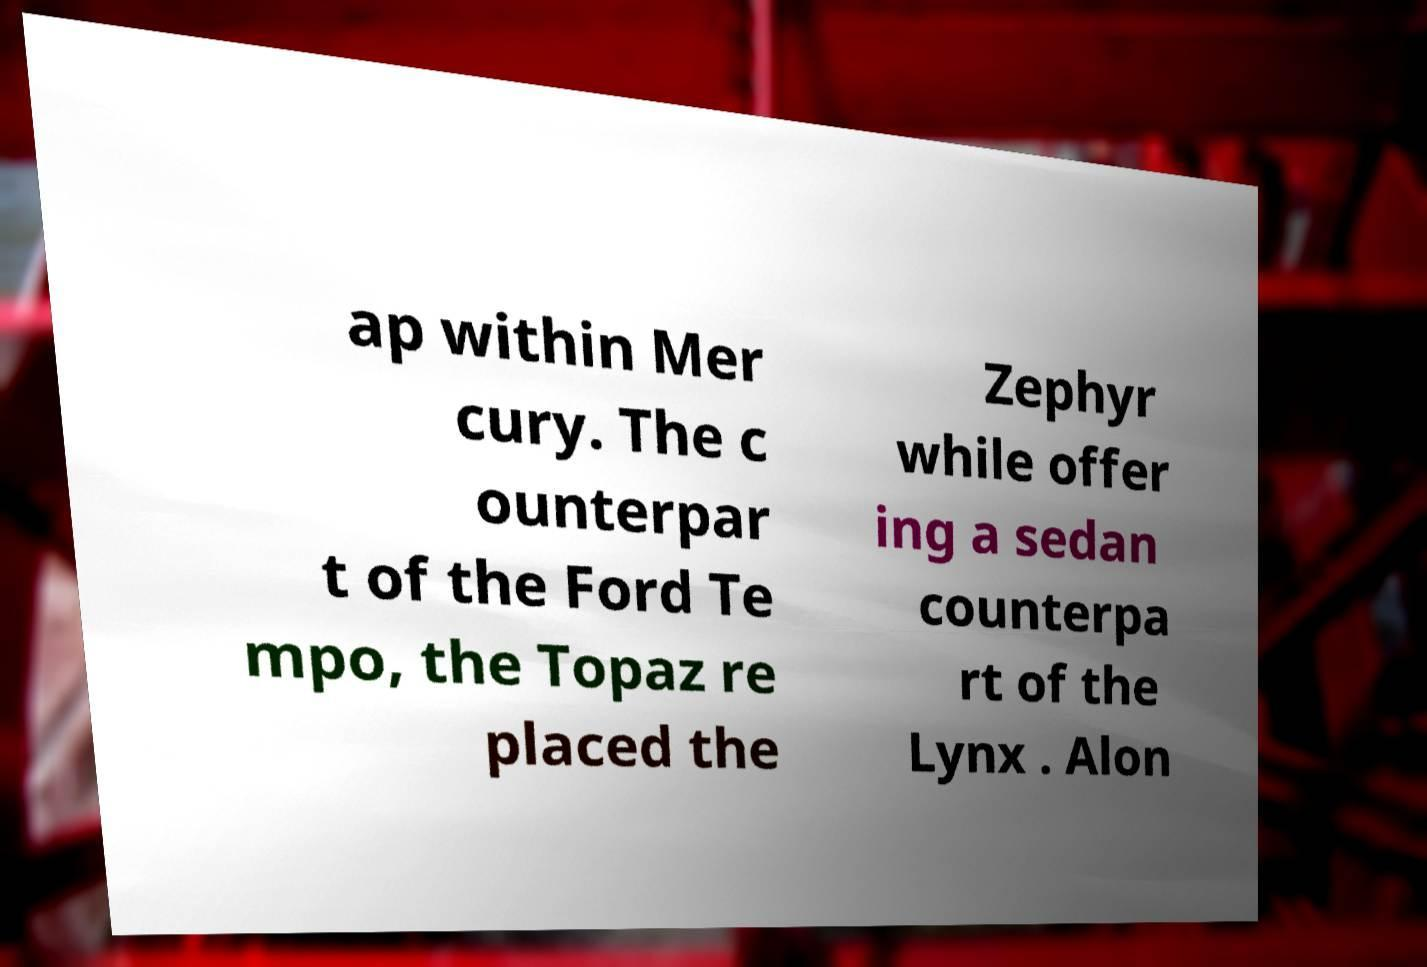There's text embedded in this image that I need extracted. Can you transcribe it verbatim? ap within Mer cury. The c ounterpar t of the Ford Te mpo, the Topaz re placed the Zephyr while offer ing a sedan counterpa rt of the Lynx . Alon 